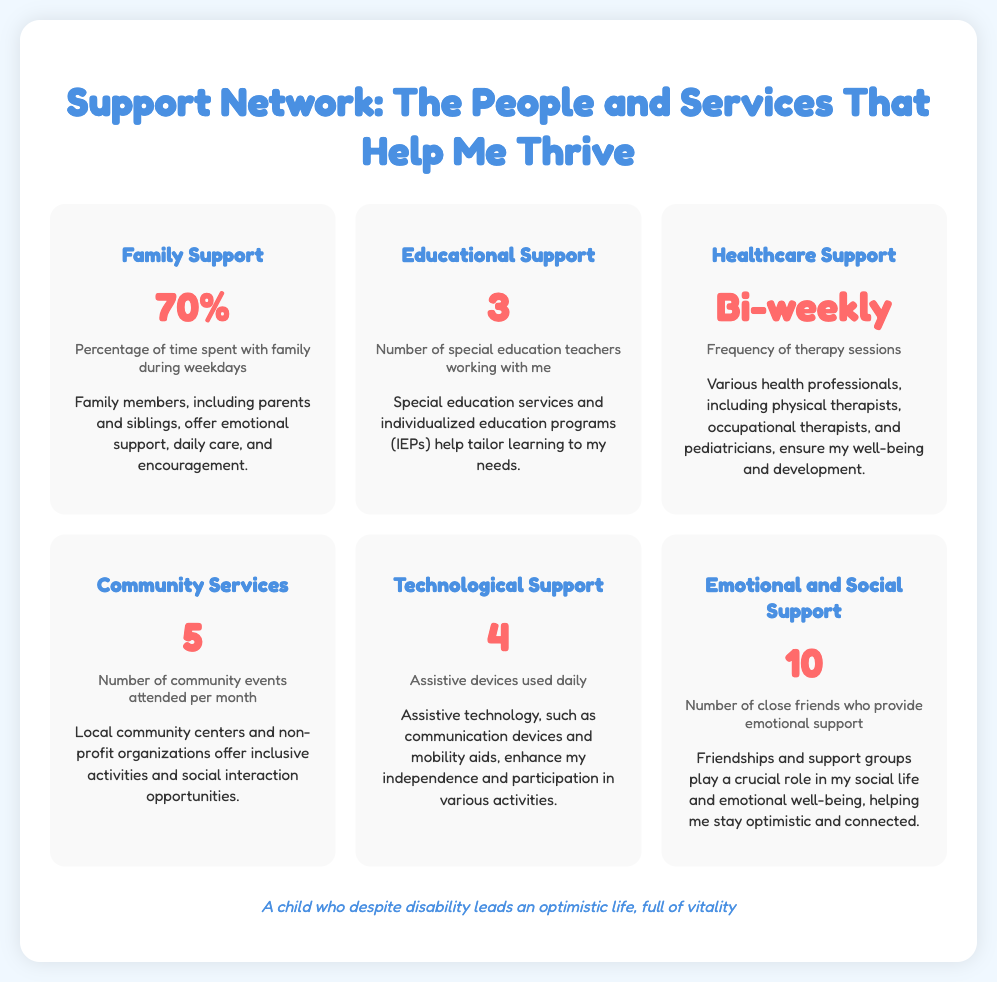What percentage of time is spent with family during weekdays? The document states that 70% of the time is spent with family during weekdays.
Answer: 70% How many special education teachers are working with me? The document mentions that there are 3 special education teachers working with the individual.
Answer: 3 How often do I have therapy sessions? The document indicates that therapy sessions occur bi-weekly.
Answer: Bi-weekly How many community events do I attend per month? The document specifies that 5 community events are attended each month.
Answer: 5 What is the number of assistive devices used daily? According to the document, 4 assistive devices are used daily.
Answer: 4 How many close friends provide emotional support? The document states that there are 10 close friends who provide emotional support.
Answer: 10 What role do family members play in my support network? Family members offer emotional support, daily care, and encouragement according to the document.
Answer: Emotional support, daily care, and encouragement What type of activities do community services offer? The document notes that community services offer inclusive activities and social interaction opportunities.
Answer: Inclusive activities and social interaction What is the main message of the infographic? The main message of the infographic is to showcase the different people and services that help the individual thrive.
Answer: Different people and services that help me thrive 